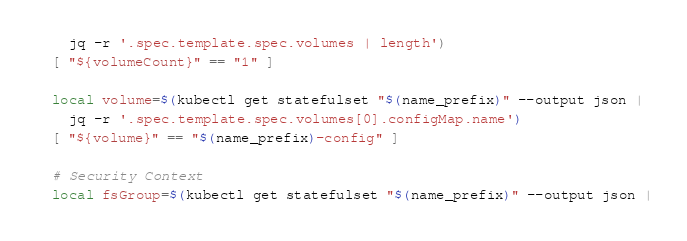<code> <loc_0><loc_0><loc_500><loc_500><_Bash_>    jq -r '.spec.template.spec.volumes | length')
  [ "${volumeCount}" == "1" ]

  local volume=$(kubectl get statefulset "$(name_prefix)" --output json |
    jq -r '.spec.template.spec.volumes[0].configMap.name')
  [ "${volume}" == "$(name_prefix)-config" ]

  # Security Context
  local fsGroup=$(kubectl get statefulset "$(name_prefix)" --output json |</code> 